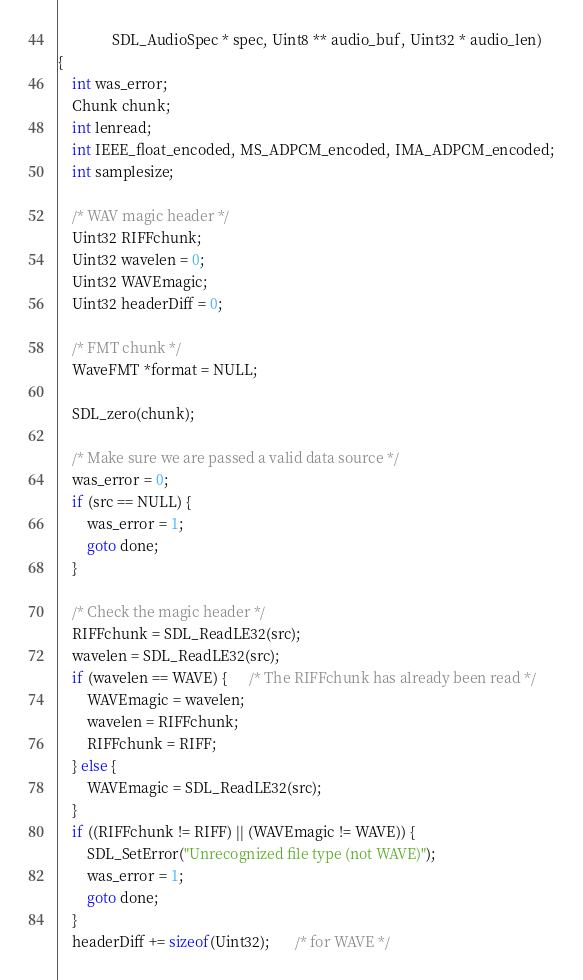Convert code to text. <code><loc_0><loc_0><loc_500><loc_500><_C_>               SDL_AudioSpec * spec, Uint8 ** audio_buf, Uint32 * audio_len)
{
    int was_error;
    Chunk chunk;
    int lenread;
    int IEEE_float_encoded, MS_ADPCM_encoded, IMA_ADPCM_encoded;
    int samplesize;

    /* WAV magic header */
    Uint32 RIFFchunk;
    Uint32 wavelen = 0;
    Uint32 WAVEmagic;
    Uint32 headerDiff = 0;

    /* FMT chunk */
    WaveFMT *format = NULL;

    SDL_zero(chunk);

    /* Make sure we are passed a valid data source */
    was_error = 0;
    if (src == NULL) {
        was_error = 1;
        goto done;
    }

    /* Check the magic header */
    RIFFchunk = SDL_ReadLE32(src);
    wavelen = SDL_ReadLE32(src);
    if (wavelen == WAVE) {      /* The RIFFchunk has already been read */
        WAVEmagic = wavelen;
        wavelen = RIFFchunk;
        RIFFchunk = RIFF;
    } else {
        WAVEmagic = SDL_ReadLE32(src);
    }
    if ((RIFFchunk != RIFF) || (WAVEmagic != WAVE)) {
        SDL_SetError("Unrecognized file type (not WAVE)");
        was_error = 1;
        goto done;
    }
    headerDiff += sizeof(Uint32);       /* for WAVE */
</code> 